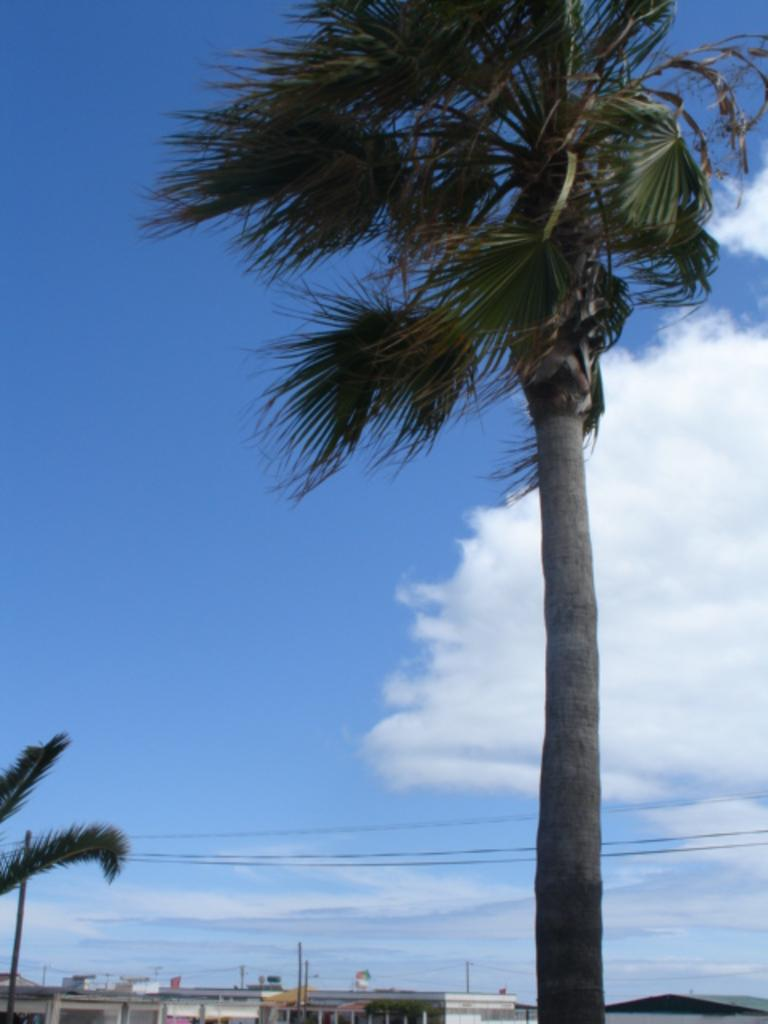What is located in the foreground of the image? There are trees in the foreground of the image. What can be seen in the background of the image? There are buildings and poles with cables in the background of the image. What is visible in the sky in the image? The sky is visible in the background of the image, and it appears to be cloudy. Can you tell me how many people are talking in the quicksand in the image? There is no quicksand or people talking in the image; it features trees in the foreground, buildings and poles with cables in the background, and a cloudy sky. What type of brush is being used to paint the buildings in the image? There is no brush or painting activity in the image; it is a photograph or illustration of the scene. 